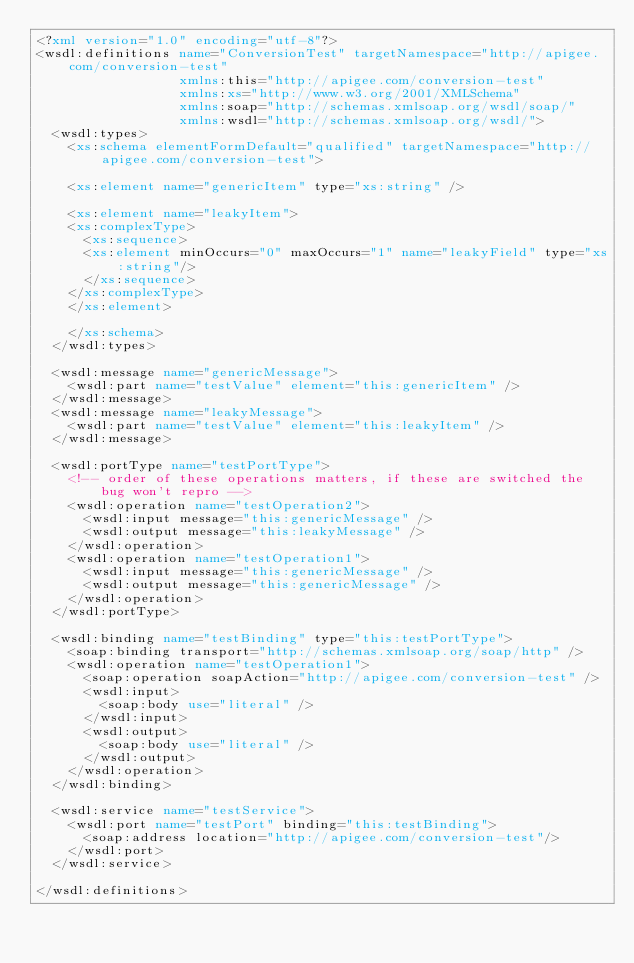Convert code to text. <code><loc_0><loc_0><loc_500><loc_500><_XML_><?xml version="1.0" encoding="utf-8"?>
<wsdl:definitions name="ConversionTest" targetNamespace="http://apigee.com/conversion-test"
                  xmlns:this="http://apigee.com/conversion-test"
                  xmlns:xs="http://www.w3.org/2001/XMLSchema"
                  xmlns:soap="http://schemas.xmlsoap.org/wsdl/soap/"
                  xmlns:wsdl="http://schemas.xmlsoap.org/wsdl/">
  <wsdl:types>
    <xs:schema elementFormDefault="qualified" targetNamespace="http://apigee.com/conversion-test">

	  <xs:element name="genericItem" type="xs:string" />

	  <xs:element name="leakyItem">
		<xs:complexType>
		  <xs:sequence>
			<xs:element minOccurs="0" maxOccurs="1" name="leakyField" type="xs:string"/>
		  </xs:sequence>
		</xs:complexType>
	  </xs:element>

    </xs:schema>
  </wsdl:types>

  <wsdl:message name="genericMessage">
    <wsdl:part name="testValue" element="this:genericItem" />
  </wsdl:message>
  <wsdl:message name="leakyMessage">
    <wsdl:part name="testValue" element="this:leakyItem" />
  </wsdl:message>

  <wsdl:portType name="testPortType">
    <!-- order of these operations matters, if these are switched the bug won't repro -->
    <wsdl:operation name="testOperation2">
      <wsdl:input message="this:genericMessage" />
      <wsdl:output message="this:leakyMessage" />
    </wsdl:operation>
    <wsdl:operation name="testOperation1">
      <wsdl:input message="this:genericMessage" />
      <wsdl:output message="this:genericMessage" />
    </wsdl:operation>
  </wsdl:portType>

  <wsdl:binding name="testBinding" type="this:testPortType">
    <soap:binding transport="http://schemas.xmlsoap.org/soap/http" />
    <wsdl:operation name="testOperation1">
      <soap:operation soapAction="http://apigee.com/conversion-test" />
      <wsdl:input>
        <soap:body use="literal" />
      </wsdl:input>
      <wsdl:output>
        <soap:body use="literal" />
      </wsdl:output>
    </wsdl:operation>
  </wsdl:binding>

  <wsdl:service name="testService">
    <wsdl:port name="testPort" binding="this:testBinding">
      <soap:address location="http://apigee.com/conversion-test"/>
    </wsdl:port>
  </wsdl:service>

</wsdl:definitions>
</code> 